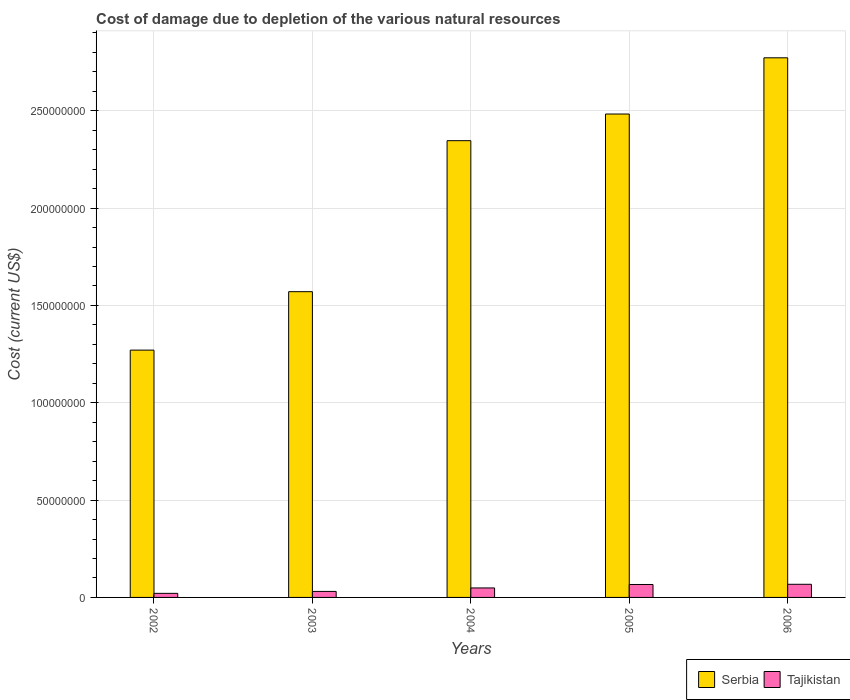How many different coloured bars are there?
Provide a succinct answer. 2. How many groups of bars are there?
Keep it short and to the point. 5. How many bars are there on the 4th tick from the left?
Your answer should be compact. 2. What is the label of the 4th group of bars from the left?
Ensure brevity in your answer.  2005. What is the cost of damage caused due to the depletion of various natural resources in Serbia in 2005?
Keep it short and to the point. 2.48e+08. Across all years, what is the maximum cost of damage caused due to the depletion of various natural resources in Serbia?
Ensure brevity in your answer.  2.77e+08. Across all years, what is the minimum cost of damage caused due to the depletion of various natural resources in Tajikistan?
Offer a terse response. 2.10e+06. In which year was the cost of damage caused due to the depletion of various natural resources in Serbia maximum?
Ensure brevity in your answer.  2006. What is the total cost of damage caused due to the depletion of various natural resources in Serbia in the graph?
Offer a very short reply. 1.04e+09. What is the difference between the cost of damage caused due to the depletion of various natural resources in Tajikistan in 2002 and that in 2006?
Ensure brevity in your answer.  -4.65e+06. What is the difference between the cost of damage caused due to the depletion of various natural resources in Tajikistan in 2006 and the cost of damage caused due to the depletion of various natural resources in Serbia in 2002?
Ensure brevity in your answer.  -1.20e+08. What is the average cost of damage caused due to the depletion of various natural resources in Serbia per year?
Ensure brevity in your answer.  2.09e+08. In the year 2002, what is the difference between the cost of damage caused due to the depletion of various natural resources in Tajikistan and cost of damage caused due to the depletion of various natural resources in Serbia?
Your answer should be very brief. -1.25e+08. What is the ratio of the cost of damage caused due to the depletion of various natural resources in Tajikistan in 2002 to that in 2006?
Offer a very short reply. 0.31. What is the difference between the highest and the second highest cost of damage caused due to the depletion of various natural resources in Tajikistan?
Offer a terse response. 1.00e+05. What is the difference between the highest and the lowest cost of damage caused due to the depletion of various natural resources in Serbia?
Your answer should be very brief. 1.50e+08. Is the sum of the cost of damage caused due to the depletion of various natural resources in Serbia in 2005 and 2006 greater than the maximum cost of damage caused due to the depletion of various natural resources in Tajikistan across all years?
Provide a succinct answer. Yes. What does the 1st bar from the left in 2005 represents?
Make the answer very short. Serbia. What does the 1st bar from the right in 2002 represents?
Your answer should be compact. Tajikistan. Does the graph contain any zero values?
Keep it short and to the point. No. Does the graph contain grids?
Your answer should be very brief. Yes. How are the legend labels stacked?
Your answer should be compact. Horizontal. What is the title of the graph?
Your answer should be compact. Cost of damage due to depletion of the various natural resources. What is the label or title of the Y-axis?
Keep it short and to the point. Cost (current US$). What is the Cost (current US$) in Serbia in 2002?
Make the answer very short. 1.27e+08. What is the Cost (current US$) of Tajikistan in 2002?
Provide a short and direct response. 2.10e+06. What is the Cost (current US$) of Serbia in 2003?
Your answer should be very brief. 1.57e+08. What is the Cost (current US$) of Tajikistan in 2003?
Keep it short and to the point. 3.09e+06. What is the Cost (current US$) of Serbia in 2004?
Provide a succinct answer. 2.35e+08. What is the Cost (current US$) of Tajikistan in 2004?
Ensure brevity in your answer.  4.87e+06. What is the Cost (current US$) of Serbia in 2005?
Make the answer very short. 2.48e+08. What is the Cost (current US$) of Tajikistan in 2005?
Offer a terse response. 6.65e+06. What is the Cost (current US$) of Serbia in 2006?
Provide a short and direct response. 2.77e+08. What is the Cost (current US$) in Tajikistan in 2006?
Provide a short and direct response. 6.75e+06. Across all years, what is the maximum Cost (current US$) of Serbia?
Ensure brevity in your answer.  2.77e+08. Across all years, what is the maximum Cost (current US$) of Tajikistan?
Your answer should be compact. 6.75e+06. Across all years, what is the minimum Cost (current US$) of Serbia?
Make the answer very short. 1.27e+08. Across all years, what is the minimum Cost (current US$) in Tajikistan?
Keep it short and to the point. 2.10e+06. What is the total Cost (current US$) in Serbia in the graph?
Offer a terse response. 1.04e+09. What is the total Cost (current US$) of Tajikistan in the graph?
Your answer should be very brief. 2.34e+07. What is the difference between the Cost (current US$) of Serbia in 2002 and that in 2003?
Give a very brief answer. -3.00e+07. What is the difference between the Cost (current US$) in Tajikistan in 2002 and that in 2003?
Offer a very short reply. -9.92e+05. What is the difference between the Cost (current US$) in Serbia in 2002 and that in 2004?
Ensure brevity in your answer.  -1.08e+08. What is the difference between the Cost (current US$) in Tajikistan in 2002 and that in 2004?
Keep it short and to the point. -2.78e+06. What is the difference between the Cost (current US$) of Serbia in 2002 and that in 2005?
Provide a succinct answer. -1.21e+08. What is the difference between the Cost (current US$) in Tajikistan in 2002 and that in 2005?
Give a very brief answer. -4.55e+06. What is the difference between the Cost (current US$) in Serbia in 2002 and that in 2006?
Ensure brevity in your answer.  -1.50e+08. What is the difference between the Cost (current US$) of Tajikistan in 2002 and that in 2006?
Give a very brief answer. -4.65e+06. What is the difference between the Cost (current US$) of Serbia in 2003 and that in 2004?
Ensure brevity in your answer.  -7.76e+07. What is the difference between the Cost (current US$) of Tajikistan in 2003 and that in 2004?
Offer a terse response. -1.78e+06. What is the difference between the Cost (current US$) in Serbia in 2003 and that in 2005?
Offer a very short reply. -9.13e+07. What is the difference between the Cost (current US$) in Tajikistan in 2003 and that in 2005?
Your response must be concise. -3.56e+06. What is the difference between the Cost (current US$) of Serbia in 2003 and that in 2006?
Make the answer very short. -1.20e+08. What is the difference between the Cost (current US$) of Tajikistan in 2003 and that in 2006?
Offer a terse response. -3.66e+06. What is the difference between the Cost (current US$) of Serbia in 2004 and that in 2005?
Ensure brevity in your answer.  -1.37e+07. What is the difference between the Cost (current US$) in Tajikistan in 2004 and that in 2005?
Provide a succinct answer. -1.78e+06. What is the difference between the Cost (current US$) of Serbia in 2004 and that in 2006?
Provide a succinct answer. -4.26e+07. What is the difference between the Cost (current US$) in Tajikistan in 2004 and that in 2006?
Keep it short and to the point. -1.88e+06. What is the difference between the Cost (current US$) of Serbia in 2005 and that in 2006?
Give a very brief answer. -2.89e+07. What is the difference between the Cost (current US$) of Tajikistan in 2005 and that in 2006?
Give a very brief answer. -1.00e+05. What is the difference between the Cost (current US$) in Serbia in 2002 and the Cost (current US$) in Tajikistan in 2003?
Provide a succinct answer. 1.24e+08. What is the difference between the Cost (current US$) in Serbia in 2002 and the Cost (current US$) in Tajikistan in 2004?
Make the answer very short. 1.22e+08. What is the difference between the Cost (current US$) of Serbia in 2002 and the Cost (current US$) of Tajikistan in 2005?
Offer a terse response. 1.20e+08. What is the difference between the Cost (current US$) in Serbia in 2002 and the Cost (current US$) in Tajikistan in 2006?
Offer a very short reply. 1.20e+08. What is the difference between the Cost (current US$) of Serbia in 2003 and the Cost (current US$) of Tajikistan in 2004?
Your response must be concise. 1.52e+08. What is the difference between the Cost (current US$) of Serbia in 2003 and the Cost (current US$) of Tajikistan in 2005?
Make the answer very short. 1.50e+08. What is the difference between the Cost (current US$) of Serbia in 2003 and the Cost (current US$) of Tajikistan in 2006?
Keep it short and to the point. 1.50e+08. What is the difference between the Cost (current US$) in Serbia in 2004 and the Cost (current US$) in Tajikistan in 2005?
Keep it short and to the point. 2.28e+08. What is the difference between the Cost (current US$) in Serbia in 2004 and the Cost (current US$) in Tajikistan in 2006?
Make the answer very short. 2.28e+08. What is the difference between the Cost (current US$) in Serbia in 2005 and the Cost (current US$) in Tajikistan in 2006?
Your answer should be very brief. 2.42e+08. What is the average Cost (current US$) in Serbia per year?
Ensure brevity in your answer.  2.09e+08. What is the average Cost (current US$) of Tajikistan per year?
Offer a very short reply. 4.69e+06. In the year 2002, what is the difference between the Cost (current US$) of Serbia and Cost (current US$) of Tajikistan?
Give a very brief answer. 1.25e+08. In the year 2003, what is the difference between the Cost (current US$) in Serbia and Cost (current US$) in Tajikistan?
Offer a very short reply. 1.54e+08. In the year 2004, what is the difference between the Cost (current US$) in Serbia and Cost (current US$) in Tajikistan?
Offer a very short reply. 2.30e+08. In the year 2005, what is the difference between the Cost (current US$) in Serbia and Cost (current US$) in Tajikistan?
Offer a very short reply. 2.42e+08. In the year 2006, what is the difference between the Cost (current US$) of Serbia and Cost (current US$) of Tajikistan?
Your response must be concise. 2.70e+08. What is the ratio of the Cost (current US$) in Serbia in 2002 to that in 2003?
Provide a succinct answer. 0.81. What is the ratio of the Cost (current US$) of Tajikistan in 2002 to that in 2003?
Your answer should be very brief. 0.68. What is the ratio of the Cost (current US$) in Serbia in 2002 to that in 2004?
Your answer should be compact. 0.54. What is the ratio of the Cost (current US$) in Tajikistan in 2002 to that in 2004?
Keep it short and to the point. 0.43. What is the ratio of the Cost (current US$) of Serbia in 2002 to that in 2005?
Your answer should be compact. 0.51. What is the ratio of the Cost (current US$) of Tajikistan in 2002 to that in 2005?
Offer a very short reply. 0.32. What is the ratio of the Cost (current US$) in Serbia in 2002 to that in 2006?
Provide a succinct answer. 0.46. What is the ratio of the Cost (current US$) in Tajikistan in 2002 to that in 2006?
Your answer should be compact. 0.31. What is the ratio of the Cost (current US$) in Serbia in 2003 to that in 2004?
Keep it short and to the point. 0.67. What is the ratio of the Cost (current US$) in Tajikistan in 2003 to that in 2004?
Offer a terse response. 0.63. What is the ratio of the Cost (current US$) of Serbia in 2003 to that in 2005?
Your answer should be very brief. 0.63. What is the ratio of the Cost (current US$) of Tajikistan in 2003 to that in 2005?
Provide a succinct answer. 0.46. What is the ratio of the Cost (current US$) of Serbia in 2003 to that in 2006?
Offer a very short reply. 0.57. What is the ratio of the Cost (current US$) in Tajikistan in 2003 to that in 2006?
Keep it short and to the point. 0.46. What is the ratio of the Cost (current US$) in Serbia in 2004 to that in 2005?
Offer a terse response. 0.94. What is the ratio of the Cost (current US$) of Tajikistan in 2004 to that in 2005?
Keep it short and to the point. 0.73. What is the ratio of the Cost (current US$) in Serbia in 2004 to that in 2006?
Provide a short and direct response. 0.85. What is the ratio of the Cost (current US$) of Tajikistan in 2004 to that in 2006?
Provide a succinct answer. 0.72. What is the ratio of the Cost (current US$) in Serbia in 2005 to that in 2006?
Your answer should be very brief. 0.9. What is the ratio of the Cost (current US$) in Tajikistan in 2005 to that in 2006?
Keep it short and to the point. 0.99. What is the difference between the highest and the second highest Cost (current US$) in Serbia?
Provide a short and direct response. 2.89e+07. What is the difference between the highest and the second highest Cost (current US$) in Tajikistan?
Provide a short and direct response. 1.00e+05. What is the difference between the highest and the lowest Cost (current US$) of Serbia?
Offer a terse response. 1.50e+08. What is the difference between the highest and the lowest Cost (current US$) of Tajikistan?
Offer a terse response. 4.65e+06. 